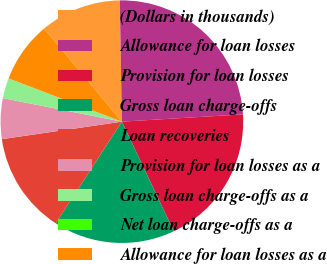Convert chart to OTSL. <chart><loc_0><loc_0><loc_500><loc_500><pie_chart><fcel>(Dollars in thousands)<fcel>Allowance for loan losses<fcel>Provision for loan losses<fcel>Gross loan charge-offs<fcel>Loan recoveries<fcel>Provision for loan losses as a<fcel>Gross loan charge-offs as a<fcel>Net loan charge-offs as a<fcel>Allowance for loan losses as a<nl><fcel>10.81%<fcel>24.32%<fcel>18.92%<fcel>16.22%<fcel>13.51%<fcel>5.41%<fcel>2.7%<fcel>0.0%<fcel>8.11%<nl></chart> 